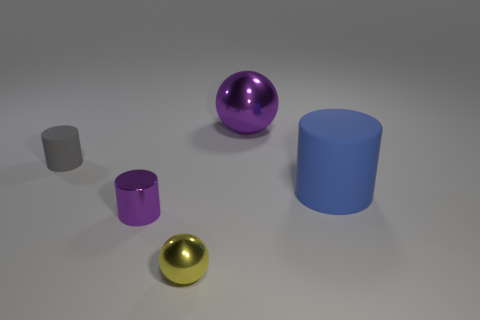There is a big object that is in front of the tiny gray rubber cylinder; is it the same shape as the tiny metal object that is in front of the tiny purple object?
Your answer should be compact. No. There is a object that is the same color as the small metallic cylinder; what is it made of?
Your answer should be very brief. Metal. Are there any purple shiny balls?
Ensure brevity in your answer.  Yes. There is a gray object that is the same shape as the tiny purple thing; what material is it?
Make the answer very short. Rubber. There is a small gray cylinder; are there any tiny cylinders to the right of it?
Your response must be concise. Yes. Is the big blue cylinder right of the tiny matte cylinder made of the same material as the yellow sphere?
Ensure brevity in your answer.  No. Are there any rubber spheres that have the same color as the big shiny ball?
Give a very brief answer. No. What is the shape of the gray matte object?
Give a very brief answer. Cylinder. There is a big thing that is to the right of the purple thing that is right of the tiny purple metal object; what color is it?
Your answer should be compact. Blue. There is a metal sphere behind the blue rubber object; what is its size?
Offer a terse response. Large. 